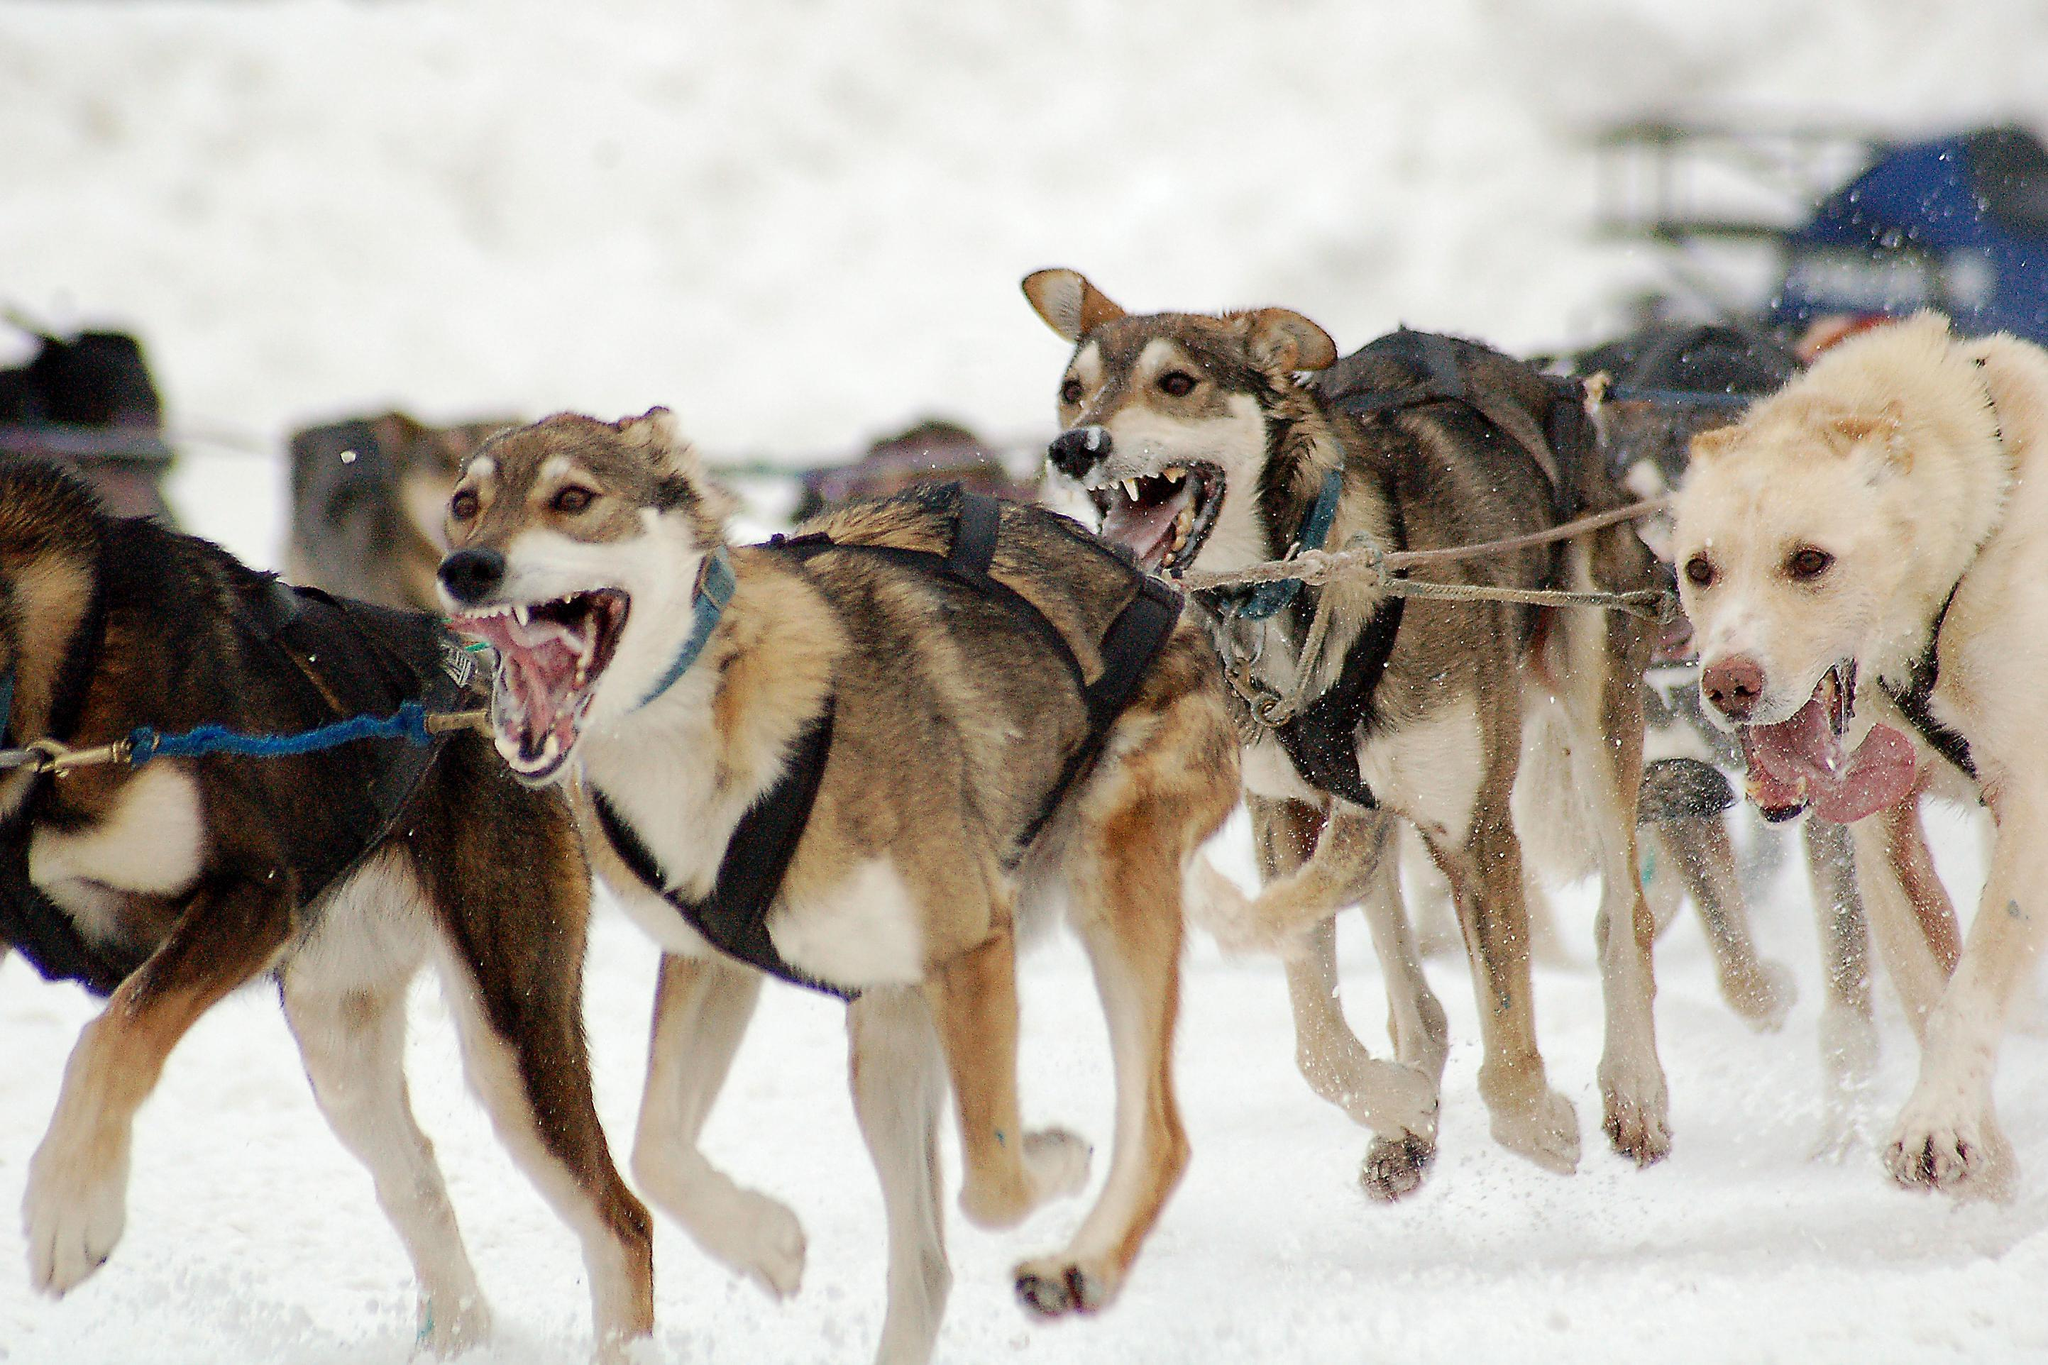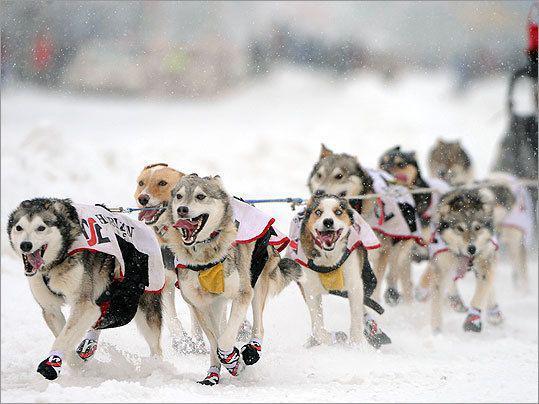The first image is the image on the left, the second image is the image on the right. Examine the images to the left and right. Is the description "There are two huskies in red harness standing on the snow." accurate? Answer yes or no. No. The first image is the image on the left, the second image is the image on the right. For the images displayed, is the sentence "Some dogs are moving forward." factually correct? Answer yes or no. Yes. 